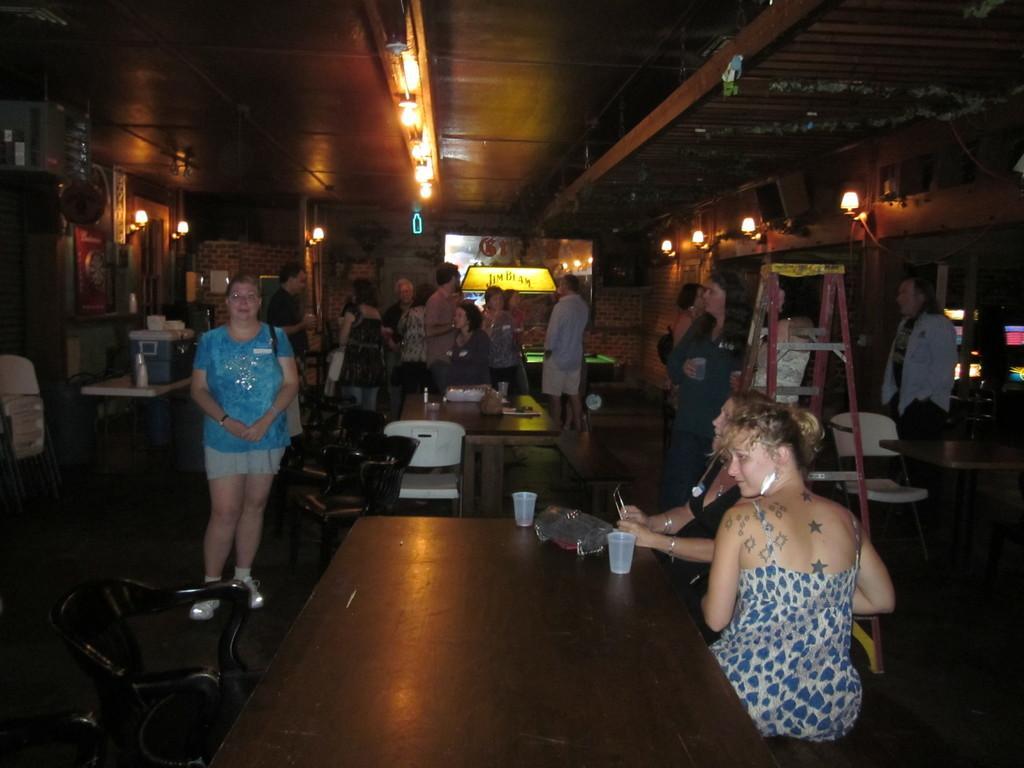How would you summarize this image in a sentence or two? In the image we can see there are people who are sitting on bench and few people are standing and on table there is glass and laptop. 